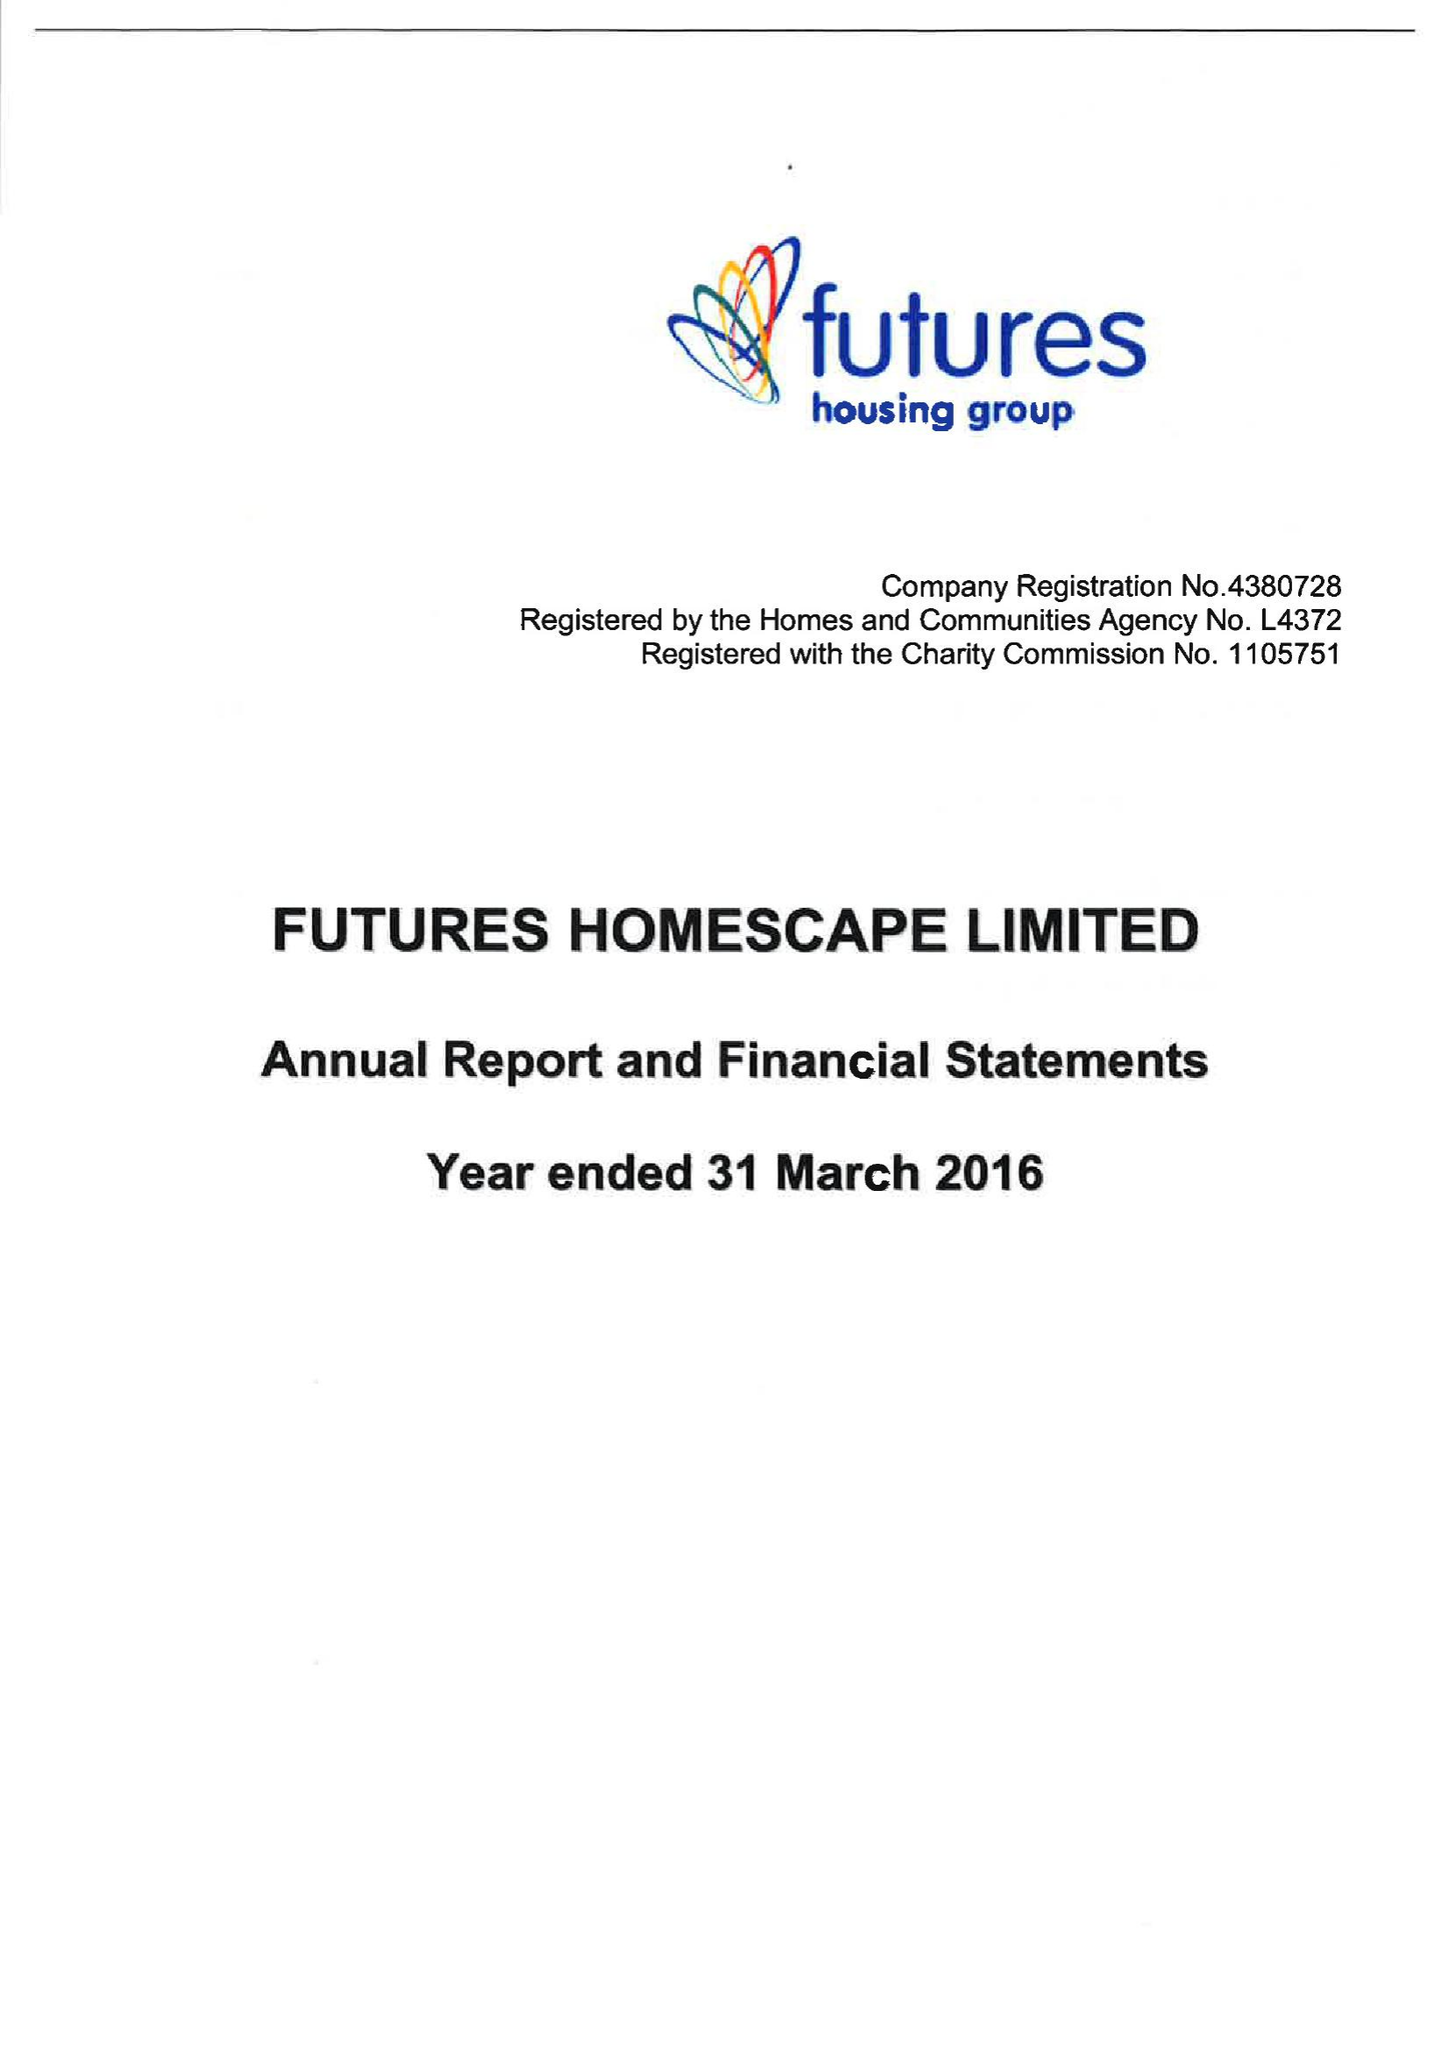What is the value for the address__postcode?
Answer the question using a single word or phrase. DE5 3SW 